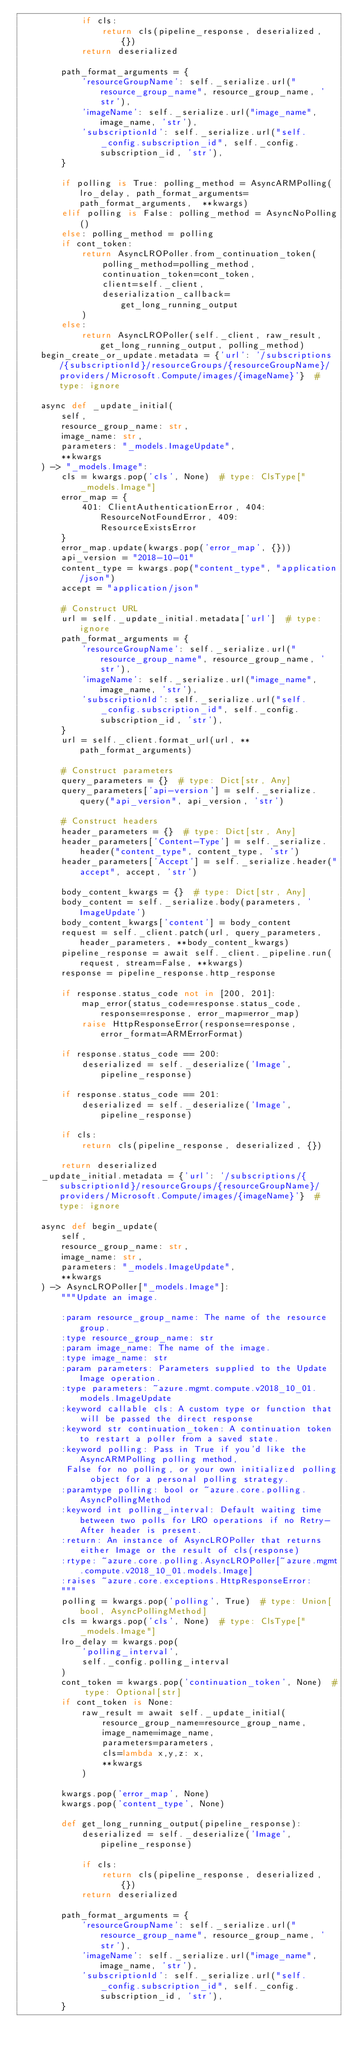Convert code to text. <code><loc_0><loc_0><loc_500><loc_500><_Python_>            if cls:
                return cls(pipeline_response, deserialized, {})
            return deserialized

        path_format_arguments = {
            'resourceGroupName': self._serialize.url("resource_group_name", resource_group_name, 'str'),
            'imageName': self._serialize.url("image_name", image_name, 'str'),
            'subscriptionId': self._serialize.url("self._config.subscription_id", self._config.subscription_id, 'str'),
        }

        if polling is True: polling_method = AsyncARMPolling(lro_delay, path_format_arguments=path_format_arguments,  **kwargs)
        elif polling is False: polling_method = AsyncNoPolling()
        else: polling_method = polling
        if cont_token:
            return AsyncLROPoller.from_continuation_token(
                polling_method=polling_method,
                continuation_token=cont_token,
                client=self._client,
                deserialization_callback=get_long_running_output
            )
        else:
            return AsyncLROPoller(self._client, raw_result, get_long_running_output, polling_method)
    begin_create_or_update.metadata = {'url': '/subscriptions/{subscriptionId}/resourceGroups/{resourceGroupName}/providers/Microsoft.Compute/images/{imageName}'}  # type: ignore

    async def _update_initial(
        self,
        resource_group_name: str,
        image_name: str,
        parameters: "_models.ImageUpdate",
        **kwargs
    ) -> "_models.Image":
        cls = kwargs.pop('cls', None)  # type: ClsType["_models.Image"]
        error_map = {
            401: ClientAuthenticationError, 404: ResourceNotFoundError, 409: ResourceExistsError
        }
        error_map.update(kwargs.pop('error_map', {}))
        api_version = "2018-10-01"
        content_type = kwargs.pop("content_type", "application/json")
        accept = "application/json"

        # Construct URL
        url = self._update_initial.metadata['url']  # type: ignore
        path_format_arguments = {
            'resourceGroupName': self._serialize.url("resource_group_name", resource_group_name, 'str'),
            'imageName': self._serialize.url("image_name", image_name, 'str'),
            'subscriptionId': self._serialize.url("self._config.subscription_id", self._config.subscription_id, 'str'),
        }
        url = self._client.format_url(url, **path_format_arguments)

        # Construct parameters
        query_parameters = {}  # type: Dict[str, Any]
        query_parameters['api-version'] = self._serialize.query("api_version", api_version, 'str')

        # Construct headers
        header_parameters = {}  # type: Dict[str, Any]
        header_parameters['Content-Type'] = self._serialize.header("content_type", content_type, 'str')
        header_parameters['Accept'] = self._serialize.header("accept", accept, 'str')

        body_content_kwargs = {}  # type: Dict[str, Any]
        body_content = self._serialize.body(parameters, 'ImageUpdate')
        body_content_kwargs['content'] = body_content
        request = self._client.patch(url, query_parameters, header_parameters, **body_content_kwargs)
        pipeline_response = await self._client._pipeline.run(request, stream=False, **kwargs)
        response = pipeline_response.http_response

        if response.status_code not in [200, 201]:
            map_error(status_code=response.status_code, response=response, error_map=error_map)
            raise HttpResponseError(response=response, error_format=ARMErrorFormat)

        if response.status_code == 200:
            deserialized = self._deserialize('Image', pipeline_response)

        if response.status_code == 201:
            deserialized = self._deserialize('Image', pipeline_response)

        if cls:
            return cls(pipeline_response, deserialized, {})

        return deserialized
    _update_initial.metadata = {'url': '/subscriptions/{subscriptionId}/resourceGroups/{resourceGroupName}/providers/Microsoft.Compute/images/{imageName}'}  # type: ignore

    async def begin_update(
        self,
        resource_group_name: str,
        image_name: str,
        parameters: "_models.ImageUpdate",
        **kwargs
    ) -> AsyncLROPoller["_models.Image"]:
        """Update an image.

        :param resource_group_name: The name of the resource group.
        :type resource_group_name: str
        :param image_name: The name of the image.
        :type image_name: str
        :param parameters: Parameters supplied to the Update Image operation.
        :type parameters: ~azure.mgmt.compute.v2018_10_01.models.ImageUpdate
        :keyword callable cls: A custom type or function that will be passed the direct response
        :keyword str continuation_token: A continuation token to restart a poller from a saved state.
        :keyword polling: Pass in True if you'd like the AsyncARMPolling polling method,
         False for no polling, or your own initialized polling object for a personal polling strategy.
        :paramtype polling: bool or ~azure.core.polling.AsyncPollingMethod
        :keyword int polling_interval: Default waiting time between two polls for LRO operations if no Retry-After header is present.
        :return: An instance of AsyncLROPoller that returns either Image or the result of cls(response)
        :rtype: ~azure.core.polling.AsyncLROPoller[~azure.mgmt.compute.v2018_10_01.models.Image]
        :raises ~azure.core.exceptions.HttpResponseError:
        """
        polling = kwargs.pop('polling', True)  # type: Union[bool, AsyncPollingMethod]
        cls = kwargs.pop('cls', None)  # type: ClsType["_models.Image"]
        lro_delay = kwargs.pop(
            'polling_interval',
            self._config.polling_interval
        )
        cont_token = kwargs.pop('continuation_token', None)  # type: Optional[str]
        if cont_token is None:
            raw_result = await self._update_initial(
                resource_group_name=resource_group_name,
                image_name=image_name,
                parameters=parameters,
                cls=lambda x,y,z: x,
                **kwargs
            )

        kwargs.pop('error_map', None)
        kwargs.pop('content_type', None)

        def get_long_running_output(pipeline_response):
            deserialized = self._deserialize('Image', pipeline_response)

            if cls:
                return cls(pipeline_response, deserialized, {})
            return deserialized

        path_format_arguments = {
            'resourceGroupName': self._serialize.url("resource_group_name", resource_group_name, 'str'),
            'imageName': self._serialize.url("image_name", image_name, 'str'),
            'subscriptionId': self._serialize.url("self._config.subscription_id", self._config.subscription_id, 'str'),
        }
</code> 